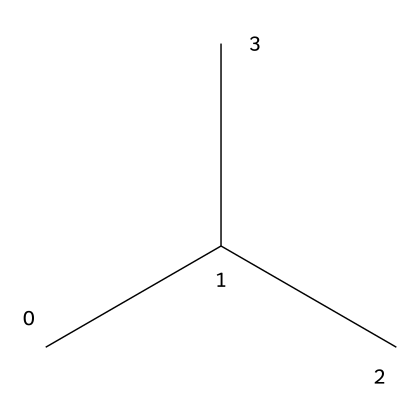What is the main component of this structure? The provided SMILES represents isopropyl, indicating that the main component is an isopropyl group.
Answer: isopropyl How many carbon atoms are in the structure? The SMILES notation shows three carbon atoms grouped together in the isopropyl structure, indicating that there are three carbon atoms in total.
Answer: three What type of polymer is this chemical related to? This structure is a derivative of polyethylene (specifically polypropylene), which is a type of thermoplastic polymer commonly used in waterproof gear.
Answer: thermoplastic polymer What is the state of this polymer at room temperature? Polyethylene and similar polymers are typically solid at room temperature due to their long-chain molecular structure, leading to higher melting points.
Answer: solid How does the branched structure affect density? The branching in isopropyl results in a lower packing efficiency compared to linear structures, thus generally leading to lower density in this type of polymer.
Answer: lower density What is the purpose of polyethylene in waterproof gear? Polyethylene provides water resistance and durability, making it suitable for applications like waterproof apparel and kayak gear.
Answer: water resistance How does the chemical structure influence flexibility? The presence of branching in this structure contributes to flexibility in the polymer chains, allowing movement while maintaining structural integrity.
Answer: flexibility 